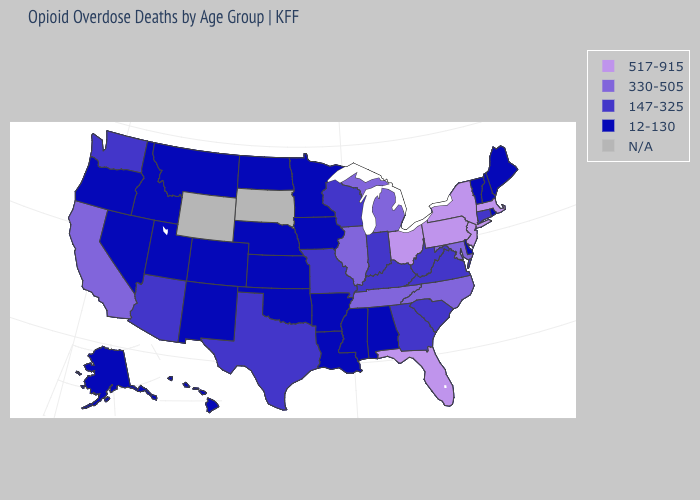What is the value of Vermont?
Short answer required. 12-130. Does the first symbol in the legend represent the smallest category?
Quick response, please. No. What is the value of Iowa?
Give a very brief answer. 12-130. Which states have the highest value in the USA?
Give a very brief answer. Florida, Massachusetts, New Jersey, New York, Ohio, Pennsylvania. Does New Jersey have the highest value in the USA?
Write a very short answer. Yes. What is the value of Minnesota?
Keep it brief. 12-130. Among the states that border Wisconsin , which have the highest value?
Give a very brief answer. Illinois, Michigan. Does Maine have the highest value in the USA?
Short answer required. No. What is the value of Illinois?
Give a very brief answer. 330-505. What is the lowest value in the MidWest?
Be succinct. 12-130. Name the states that have a value in the range 517-915?
Concise answer only. Florida, Massachusetts, New Jersey, New York, Ohio, Pennsylvania. What is the value of Louisiana?
Quick response, please. 12-130. What is the value of South Dakota?
Answer briefly. N/A. What is the lowest value in states that border Texas?
Keep it brief. 12-130. 